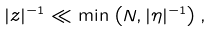Convert formula to latex. <formula><loc_0><loc_0><loc_500><loc_500>| z | ^ { - 1 } \ll \min \left ( N , | \eta | ^ { - 1 } \right ) ,</formula> 